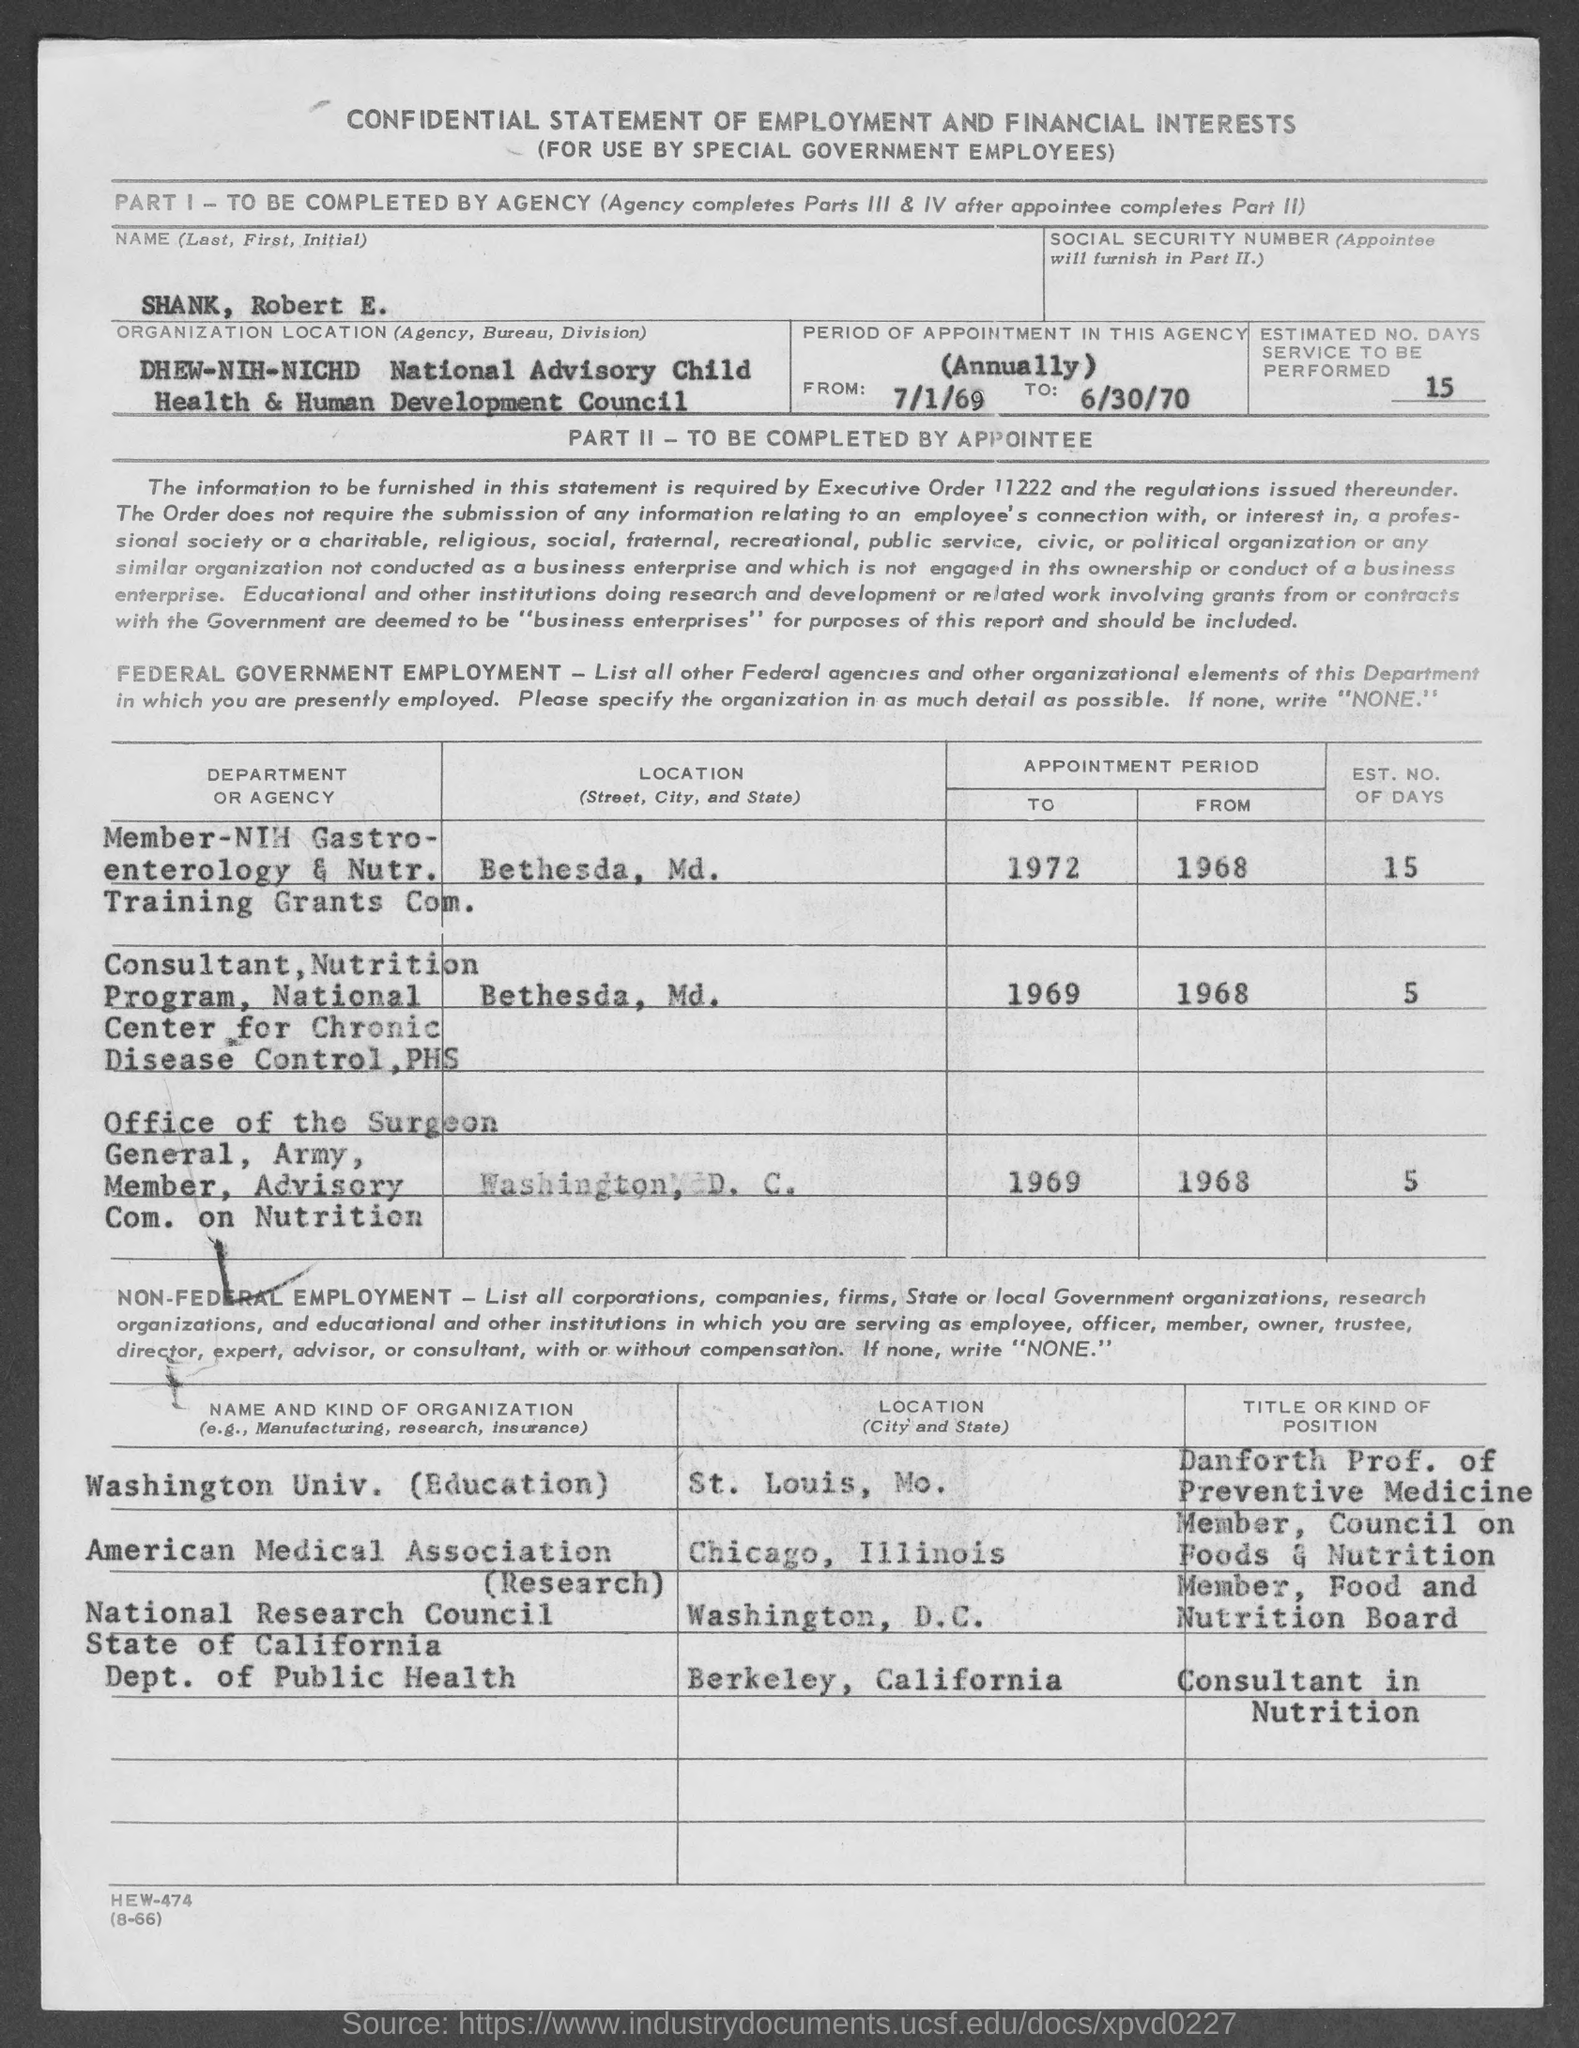What is the Name?
Provide a short and direct response. SHANK, ROBERT E. What is the Estimated No. Days service will be performed?
Your response must be concise. 15. 